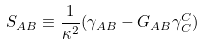<formula> <loc_0><loc_0><loc_500><loc_500>S _ { A B } \equiv \frac { 1 } { \kappa ^ { 2 } } ( \gamma _ { A B } - G _ { A B } \gamma ^ { C } _ { C } )</formula> 